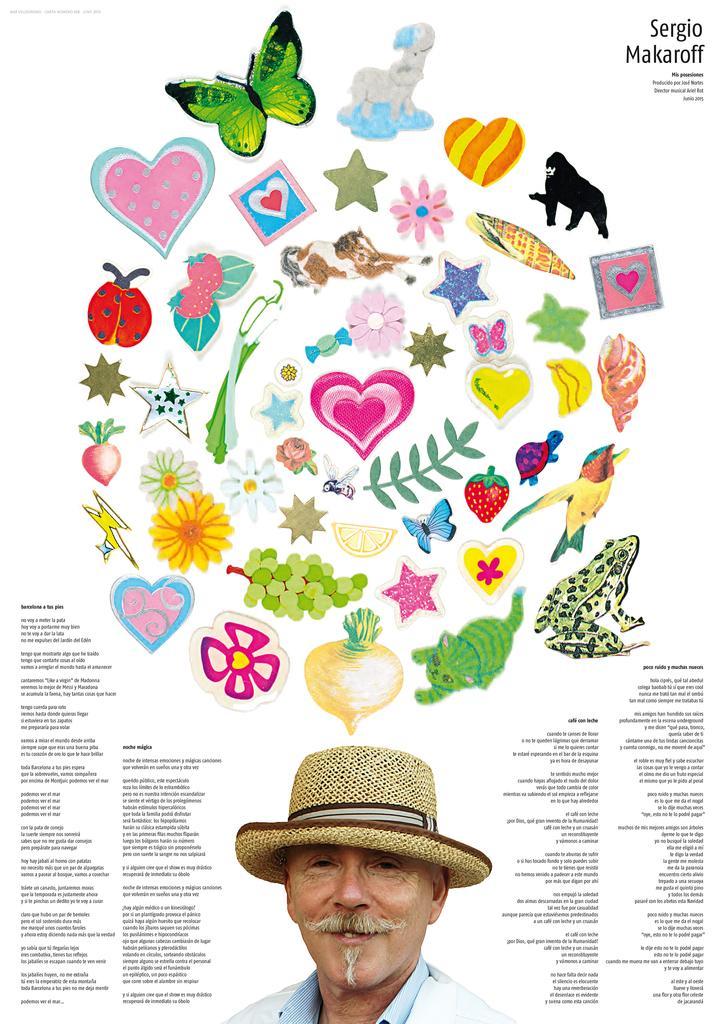Describe this image in one or two sentences. In this picture we can see a poster, in the poster we can see some text, a man and pictures of few animals, flowers, insects and fruits. 